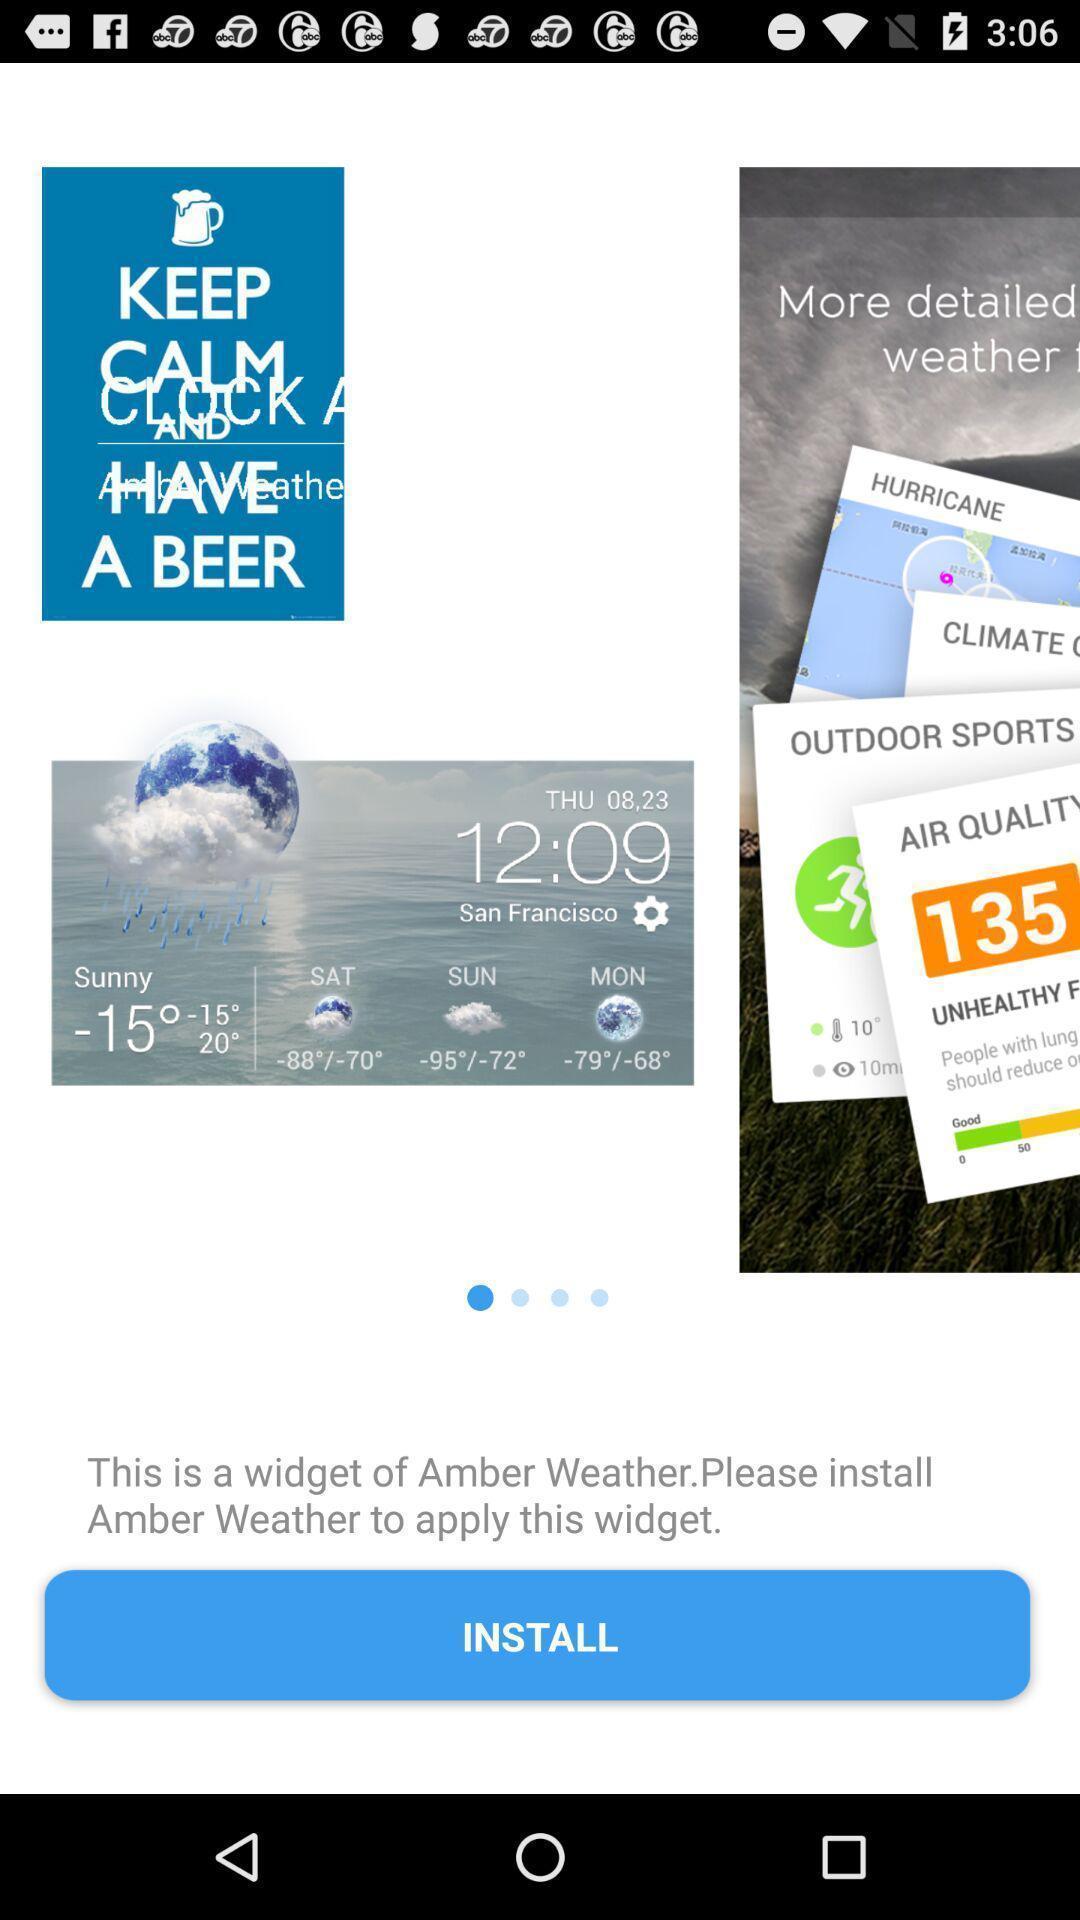Summarize the information in this screenshot. Page displaying option to install a widget. 